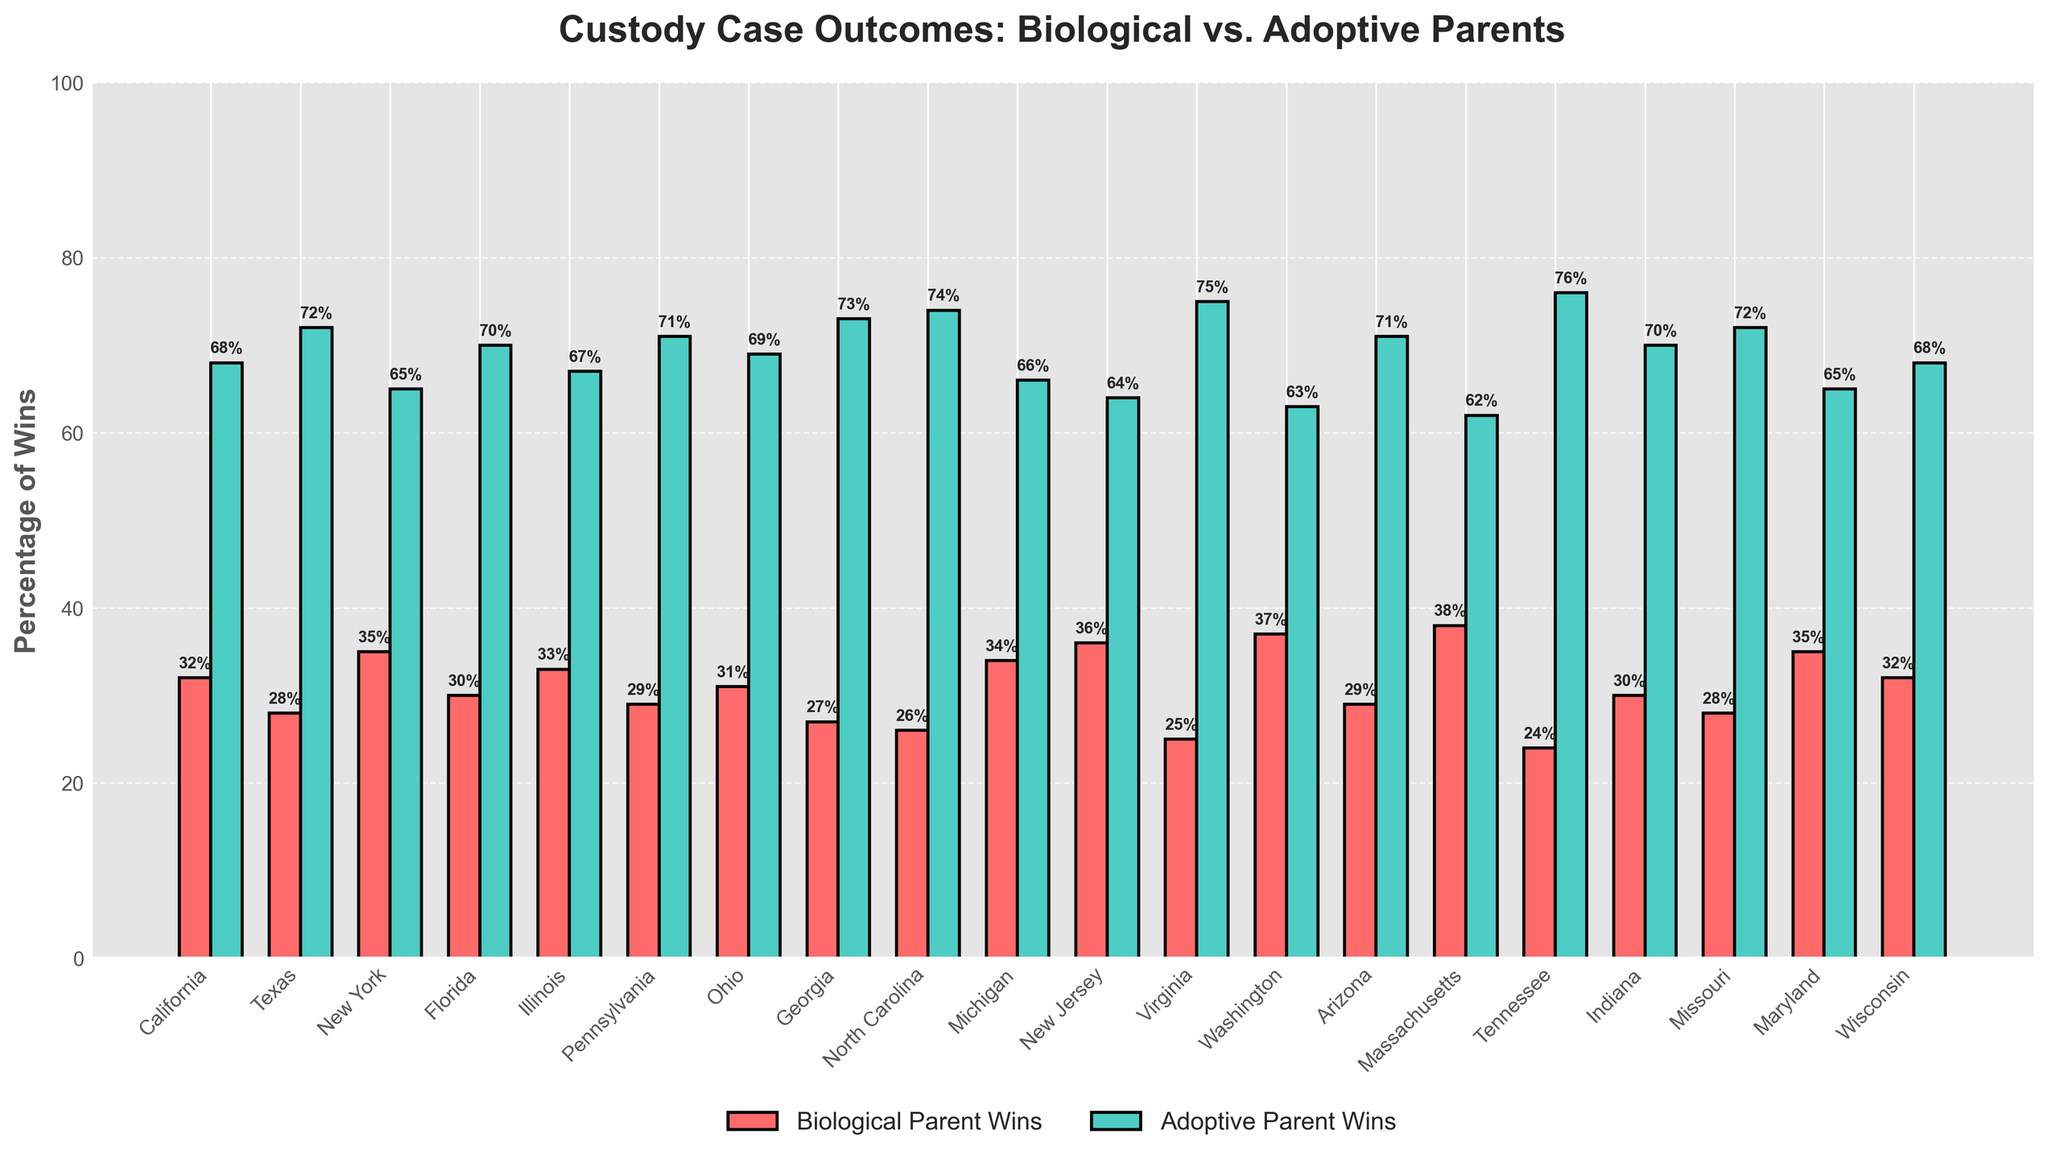Which state has the highest percentage of wins for biological parents? The state with the highest bar for 'Biological Parent Wins' is Massachusetts at 38%.
Answer: Massachusetts Which state has the highest percentage of wins for adoptive parents? The state with the highest bar for 'Adoptive Parent Wins' is Virginia at 75%.
Answer: Virginia What is the difference in win percentages between biological and adoptive parents in Texas? The percentage of wins for biological parents in Texas is 28%, and for adoptive parents, it is 72%. The difference is 72% - 28% = 44%.
Answer: 44% How many states have a higher percentage of wins for biological parents compared to Texas? Identify states where the 'Biological Parent Wins' bar is taller than 28%. They are California, New York, Illinois, Michigan, New Jersey, Washington, Massachusetts, Maryland, and Wisconsin. Count of these states is 9.
Answer: 9 What is the average percentage of wins for biological parents across all states? Sum the percentages for biological parents (32 + 28 + 35 + 30 + 33 + 29 + 31 + 27 + 26 + 34 + 36 + 25 + 37 + 29 + 38 + 24 + 30 + 28 + 35 + 32) = 589, then divide by the number of states, which is 20. 589 / 20 = 29.45%.
Answer: 29.45% In which state is the win percentage for adoptive parents 69%? Look at the label above the bar for 'Adoptive Parent Wins' at 69%, which corresponds to Ohio.
Answer: Ohio Which states have an equal percentage of wins for biological and adoptive parents? No state would have the same percentage of wins for both biological and adoptive parents since all bars for each state differ.
Answer: None In New Jersey, how many percentage points higher are the adoptive parents' wins compared to biological parents? The percentage for adoptive parents in New Jersey is 64%, and for biological parents, it is 36%. The difference is 64% - 36% = 28%.
Answer: 28% What is the percentage difference between biological and adoptive wins in Florida and Wisconsin? In Florida: 70% (adoptive) - 30% (biological) = 40%. In Wisconsin: 68% (adoptive) - 32% (biological) = 36%. The difference in these differences is 40% - 36% = 4%.
Answer: 4% Is there any state where biological parents' win percentage is 10 percentage points higher than that of another state? Compare differences between win percentages of biological parents across states. Massachusetts (38%) is exactly 10 percentage points higher than Pennsylvania (28%).
Answer: Yes 